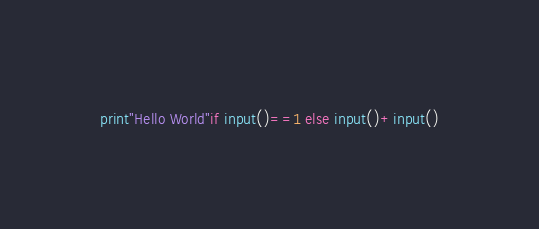<code> <loc_0><loc_0><loc_500><loc_500><_Python_>print"Hello World"if input()==1 else input()+input()</code> 